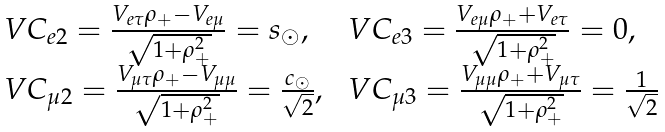<formula> <loc_0><loc_0><loc_500><loc_500>\begin{array} { l l } \ V C _ { e 2 } = \frac { V _ { e \tau } \rho _ { + } - V _ { e \mu } } { \sqrt { 1 + \rho _ { + } ^ { 2 } } } = s _ { \odot } , & \ V C _ { e 3 } = \frac { V _ { e \mu } \rho _ { + } + V _ { e \tau } } { \sqrt { 1 + \rho _ { + } ^ { 2 } } } = 0 , \\ \ V C _ { \mu 2 } = \frac { V _ { \mu \tau } \rho _ { + } - V _ { \mu \mu } } { \sqrt { 1 + \rho _ { + } ^ { 2 } } } = \frac { c _ { \odot } } { \sqrt { 2 } } , & \ V C _ { \mu 3 } = \frac { V _ { \mu \mu } \rho _ { + } + V _ { \mu \tau } } { \sqrt { 1 + \rho _ { + } ^ { 2 } } } = \frac { 1 } { \sqrt { 2 } } \end{array}</formula> 